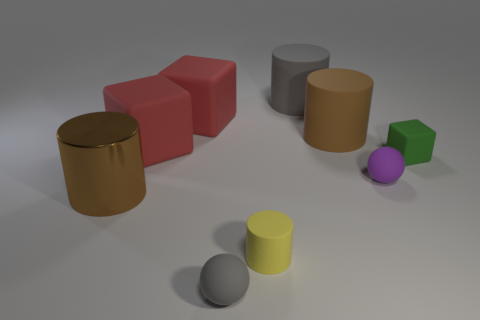What size is the gray rubber thing that is the same shape as the small purple thing?
Your answer should be very brief. Small. What is the material of the cylinder that is left of the rubber cylinder in front of the brown cylinder in front of the tiny purple thing?
Your answer should be compact. Metal. What is the color of the other metal thing that is the same shape as the large gray thing?
Provide a succinct answer. Brown. Do the big object in front of the tiny green matte thing and the large thing right of the big gray cylinder have the same color?
Your response must be concise. Yes. Are there more brown cylinders on the right side of the yellow rubber cylinder than big cyan shiny cubes?
Give a very brief answer. Yes. How many other things are the same size as the purple ball?
Make the answer very short. 3. How many things are on the right side of the metal object and to the left of the purple rubber ball?
Your response must be concise. 6. Is the gray thing that is left of the gray cylinder made of the same material as the purple thing?
Provide a short and direct response. Yes. There is a large red matte object behind the brown object behind the small matte ball behind the large brown metallic cylinder; what is its shape?
Offer a very short reply. Cube. Are there the same number of tiny cylinders on the right side of the small rubber cube and large cylinders in front of the tiny gray object?
Make the answer very short. Yes. 